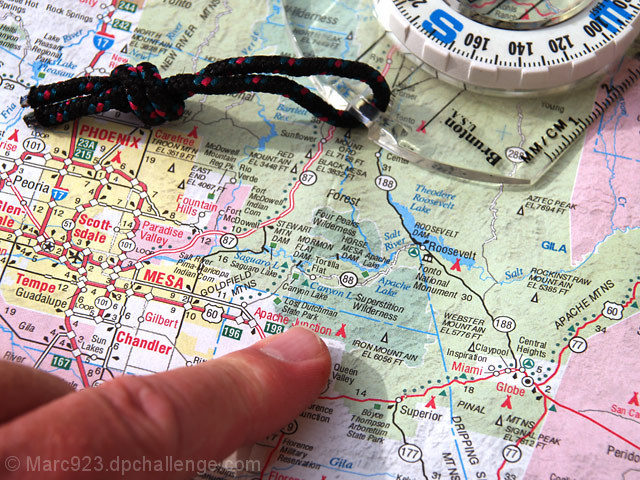Are the texture details of the main subject well preserved? Yes, the texture details of the map and the compass are well preserved, providing a clear and crisp representation of geographical information and the compass's intricate details, including its needle and degree markings. 